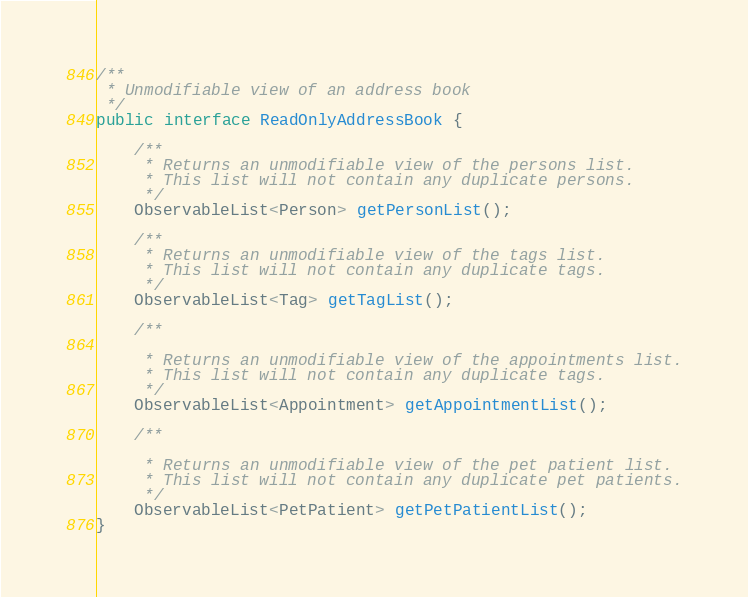Convert code to text. <code><loc_0><loc_0><loc_500><loc_500><_Java_>
/**
 * Unmodifiable view of an address book
 */
public interface ReadOnlyAddressBook {

    /**
     * Returns an unmodifiable view of the persons list.
     * This list will not contain any duplicate persons.
     */
    ObservableList<Person> getPersonList();

    /**
     * Returns an unmodifiable view of the tags list.
     * This list will not contain any duplicate tags.
     */
    ObservableList<Tag> getTagList();

    /**

     * Returns an unmodifiable view of the appointments list.
     * This list will not contain any duplicate tags.
     */
    ObservableList<Appointment> getAppointmentList();

    /**

     * Returns an unmodifiable view of the pet patient list.
     * This list will not contain any duplicate pet patients.
     */
    ObservableList<PetPatient> getPetPatientList();
}
</code> 